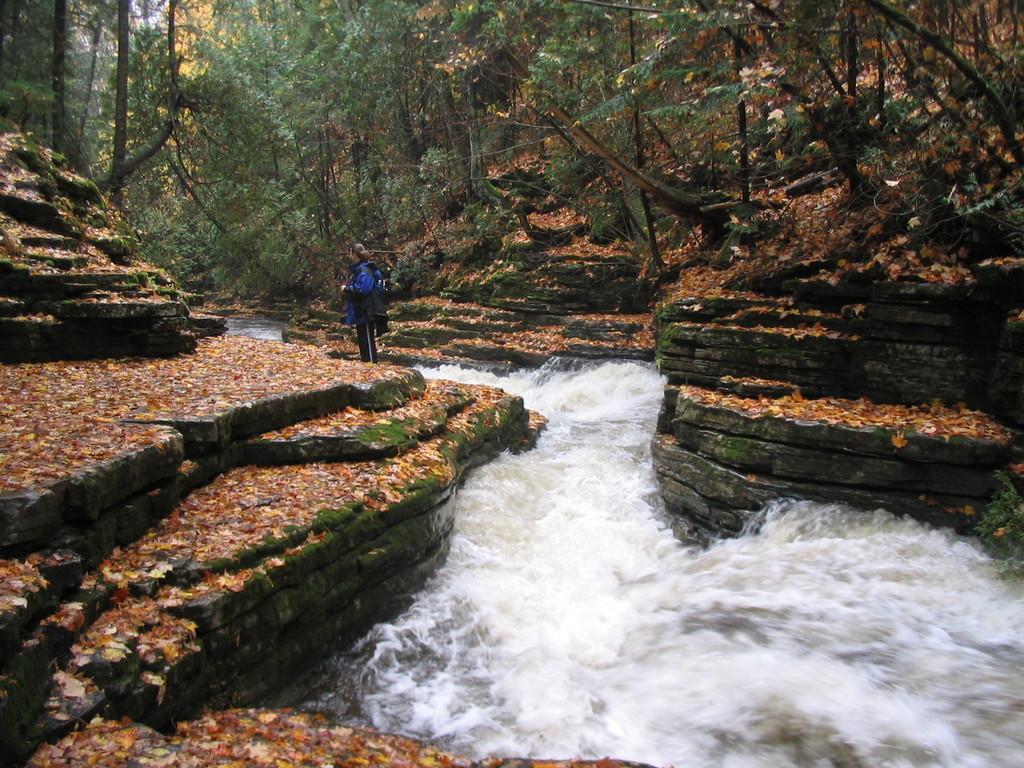Could you give a brief overview of what you see in this image? In the center of the image there is a woman standing on the ground. At the bottom of the image we can see leaves and water. In the background we can see water, trees and plants. 